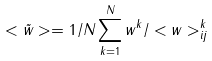<formula> <loc_0><loc_0><loc_500><loc_500>< \tilde { w } > = 1 / N \sum _ { k = 1 } ^ { N } w ^ { k } / < w > ^ { k } _ { i j }</formula> 